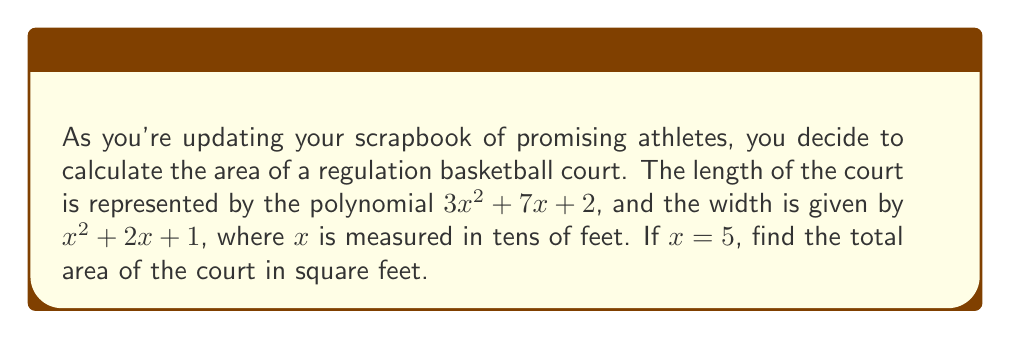Show me your answer to this math problem. Let's approach this step-by-step:

1) First, we need to calculate the length of the court:
   Length = $3x^2 + 7x + 2$, where $x = 5$
   $$ 3(5)^2 + 7(5) + 2 = 3(25) + 35 + 2 = 75 + 35 + 2 = 112 $$

2) Now, let's calculate the width of the court:
   Width = $x^2 + 2x + 1$, where $x = 5$
   $$ 5^2 + 2(5) + 1 = 25 + 10 + 1 = 36 $$

3) Remember, $x$ is measured in tens of feet. So we need to multiply our results by 10:
   Actual length = $112 \times 10 = 1120$ feet
   Actual width = $36 \times 10 = 360$ feet

4) To find the area, we multiply length by width:
   $$ \text{Area} = 1120 \times 360 = 403,200 \text{ square feet} $$

Therefore, the total area of the basketball court is 403,200 square feet.
Answer: 403,200 square feet 